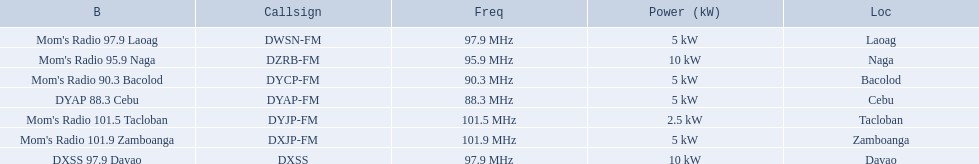Which stations broadcast in dyap-fm? Mom's Radio 97.9 Laoag, Mom's Radio 95.9 Naga, Mom's Radio 90.3 Bacolod, DYAP 88.3 Cebu, Mom's Radio 101.5 Tacloban, Mom's Radio 101.9 Zamboanga, DXSS 97.9 Davao. Of those stations which broadcast in dyap-fm, which stations broadcast with 5kw of power or under? Mom's Radio 97.9 Laoag, Mom's Radio 90.3 Bacolod, DYAP 88.3 Cebu, Mom's Radio 101.5 Tacloban, Mom's Radio 101.9 Zamboanga. Of those stations that broadcast with 5kw of power or under, which broadcasts with the least power? Mom's Radio 101.5 Tacloban. 